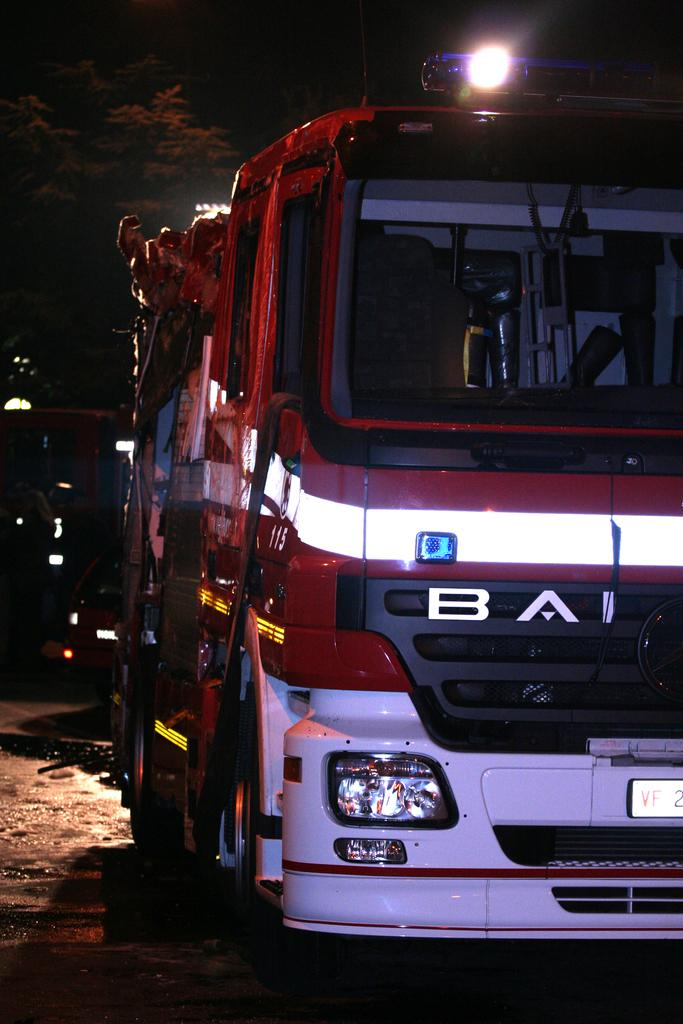What is the main subject in the foreground of the image? There is a vehicle in the foreground of the image. What can be seen in the background of the image? There are trees and lights in the background of the image. What is the ground surface like in the image? There is a walkway at the bottom of the image. How many pizzas are being stretched by the vehicle in the image? There are no pizzas or stretching actions present in the image. How many legs does the vehicle have in the image? The vehicle is not a living creature, so it does not have legs. 